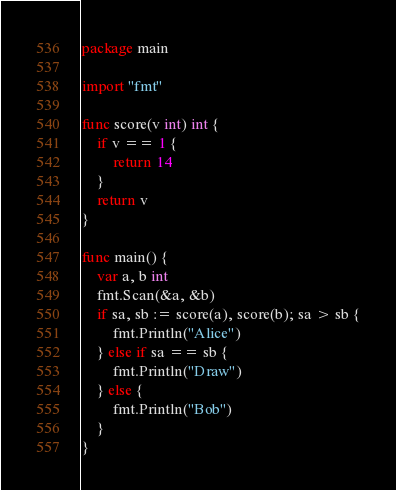Convert code to text. <code><loc_0><loc_0><loc_500><loc_500><_Go_>package main

import "fmt"

func score(v int) int {
	if v == 1 {
		return 14
	}
	return v
}

func main() {
	var a, b int
	fmt.Scan(&a, &b)
	if sa, sb := score(a), score(b); sa > sb {
		fmt.Println("Alice")
	} else if sa == sb {
		fmt.Println("Draw")
	} else {
		fmt.Println("Bob")
	}
}
</code> 